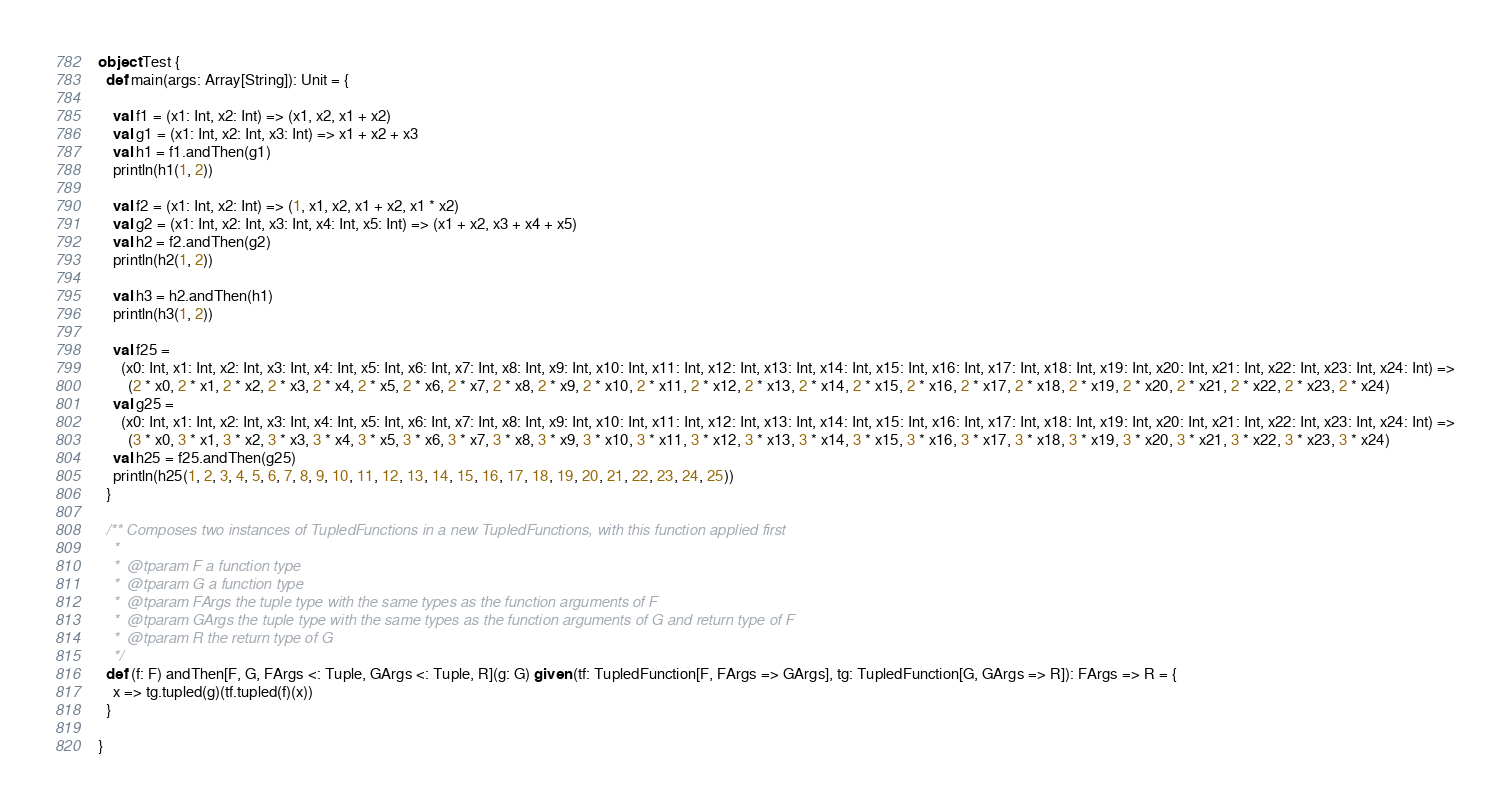Convert code to text. <code><loc_0><loc_0><loc_500><loc_500><_Scala_>object Test {
  def main(args: Array[String]): Unit = {

    val f1 = (x1: Int, x2: Int) => (x1, x2, x1 + x2)
    val g1 = (x1: Int, x2: Int, x3: Int) => x1 + x2 + x3
    val h1 = f1.andThen(g1)
    println(h1(1, 2))

    val f2 = (x1: Int, x2: Int) => (1, x1, x2, x1 + x2, x1 * x2)
    val g2 = (x1: Int, x2: Int, x3: Int, x4: Int, x5: Int) => (x1 + x2, x3 + x4 + x5)
    val h2 = f2.andThen(g2)
    println(h2(1, 2))

    val h3 = h2.andThen(h1)
    println(h3(1, 2))

    val f25 =
      (x0: Int, x1: Int, x2: Int, x3: Int, x4: Int, x5: Int, x6: Int, x7: Int, x8: Int, x9: Int, x10: Int, x11: Int, x12: Int, x13: Int, x14: Int, x15: Int, x16: Int, x17: Int, x18: Int, x19: Int, x20: Int, x21: Int, x22: Int, x23: Int, x24: Int) =>
        (2 * x0, 2 * x1, 2 * x2, 2 * x3, 2 * x4, 2 * x5, 2 * x6, 2 * x7, 2 * x8, 2 * x9, 2 * x10, 2 * x11, 2 * x12, 2 * x13, 2 * x14, 2 * x15, 2 * x16, 2 * x17, 2 * x18, 2 * x19, 2 * x20, 2 * x21, 2 * x22, 2 * x23, 2 * x24)
    val g25 =
      (x0: Int, x1: Int, x2: Int, x3: Int, x4: Int, x5: Int, x6: Int, x7: Int, x8: Int, x9: Int, x10: Int, x11: Int, x12: Int, x13: Int, x14: Int, x15: Int, x16: Int, x17: Int, x18: Int, x19: Int, x20: Int, x21: Int, x22: Int, x23: Int, x24: Int) =>
        (3 * x0, 3 * x1, 3 * x2, 3 * x3, 3 * x4, 3 * x5, 3 * x6, 3 * x7, 3 * x8, 3 * x9, 3 * x10, 3 * x11, 3 * x12, 3 * x13, 3 * x14, 3 * x15, 3 * x16, 3 * x17, 3 * x18, 3 * x19, 3 * x20, 3 * x21, 3 * x22, 3 * x23, 3 * x24)
    val h25 = f25.andThen(g25)
    println(h25(1, 2, 3, 4, 5, 6, 7, 8, 9, 10, 11, 12, 13, 14, 15, 16, 17, 18, 19, 20, 21, 22, 23, 24, 25))
  }

  /** Composes two instances of TupledFunctions in a new TupledFunctions, with this function applied first
    *
    *  @tparam F a function type
    *  @tparam G a function type
    *  @tparam FArgs the tuple type with the same types as the function arguments of F
    *  @tparam GArgs the tuple type with the same types as the function arguments of G and return type of F
    *  @tparam R the return type of G
    */
  def (f: F) andThen[F, G, FArgs <: Tuple, GArgs <: Tuple, R](g: G) given (tf: TupledFunction[F, FArgs => GArgs], tg: TupledFunction[G, GArgs => R]): FArgs => R = {
    x => tg.tupled(g)(tf.tupled(f)(x))
  }

}
</code> 